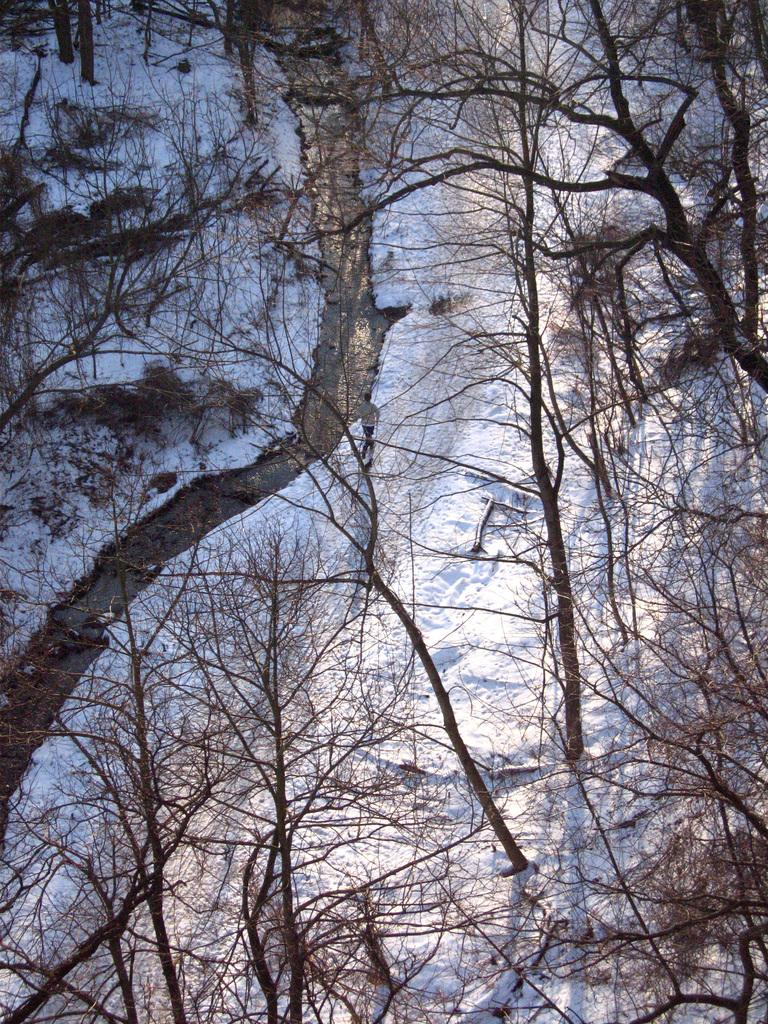What type of vegetation is present in the image? There are trees in the image. What is covering the ground at the bottom of the image? There is snow at the bottom of the image. Where is the crate located in the image? There is no crate present in the image. What type of furniture can be seen in the bedroom in the image? There is no bedroom or furniture present in the image. 